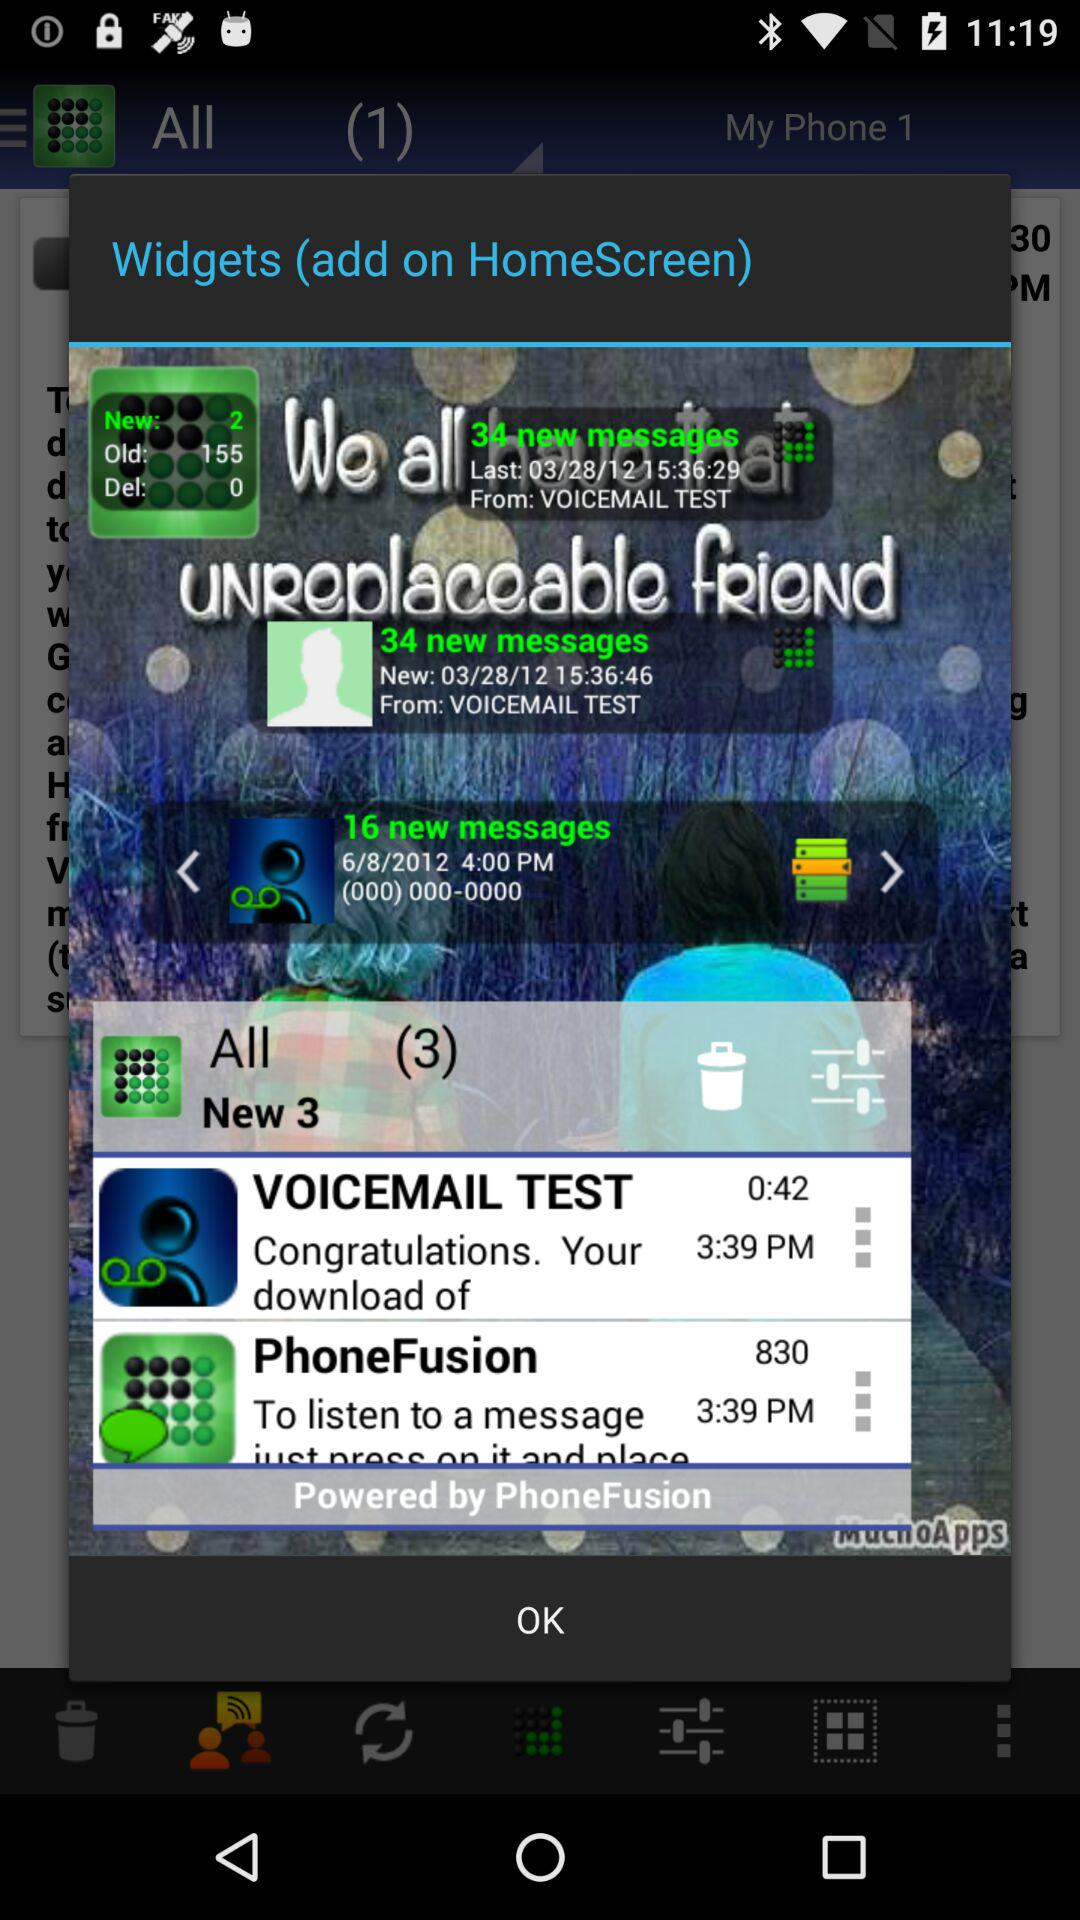What is the number of all messages? The number of all messages is 3. 